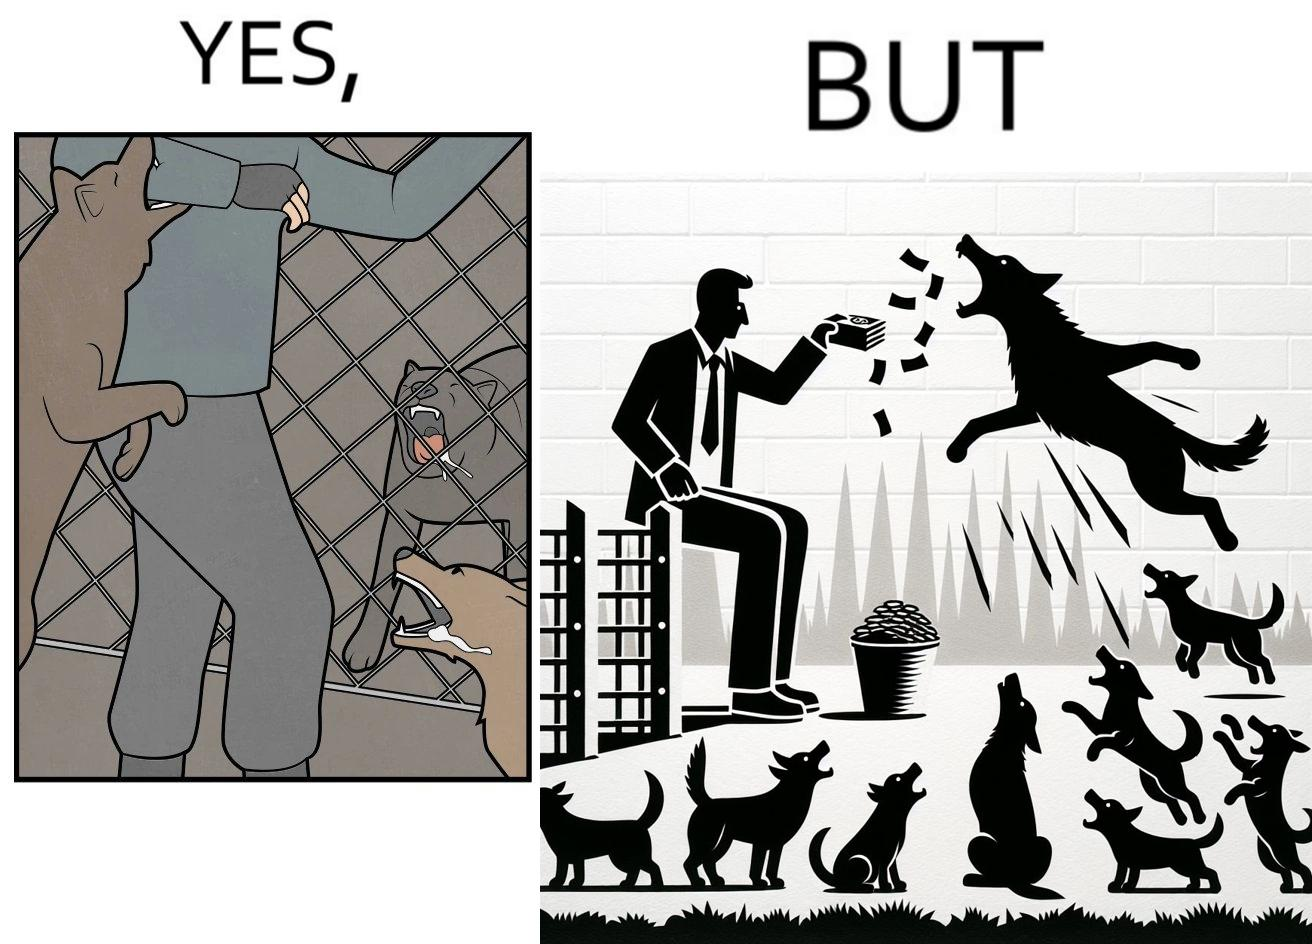Would you classify this image as satirical? Yes, this image is satirical. 